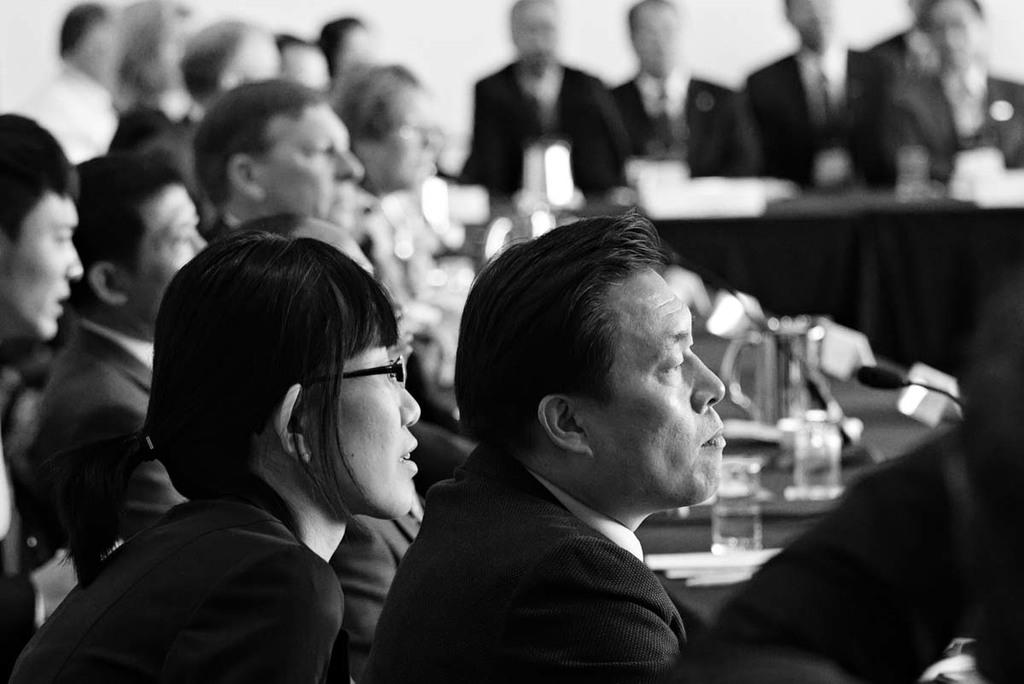What is the color scheme of the image? The image is in black and white. What are the people in the image doing? The people are sitting at a table. What objects can be seen on the table? There are microphones, glasses, and papers on the table. What type of plate is being used for the event in the image? There is no plate visible in the image, and no event is taking place. 